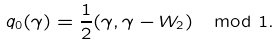<formula> <loc_0><loc_0><loc_500><loc_500>q _ { 0 } ( \gamma ) = \frac { 1 } { 2 } ( \gamma , \gamma - W _ { 2 } ) \mod 1 .</formula> 